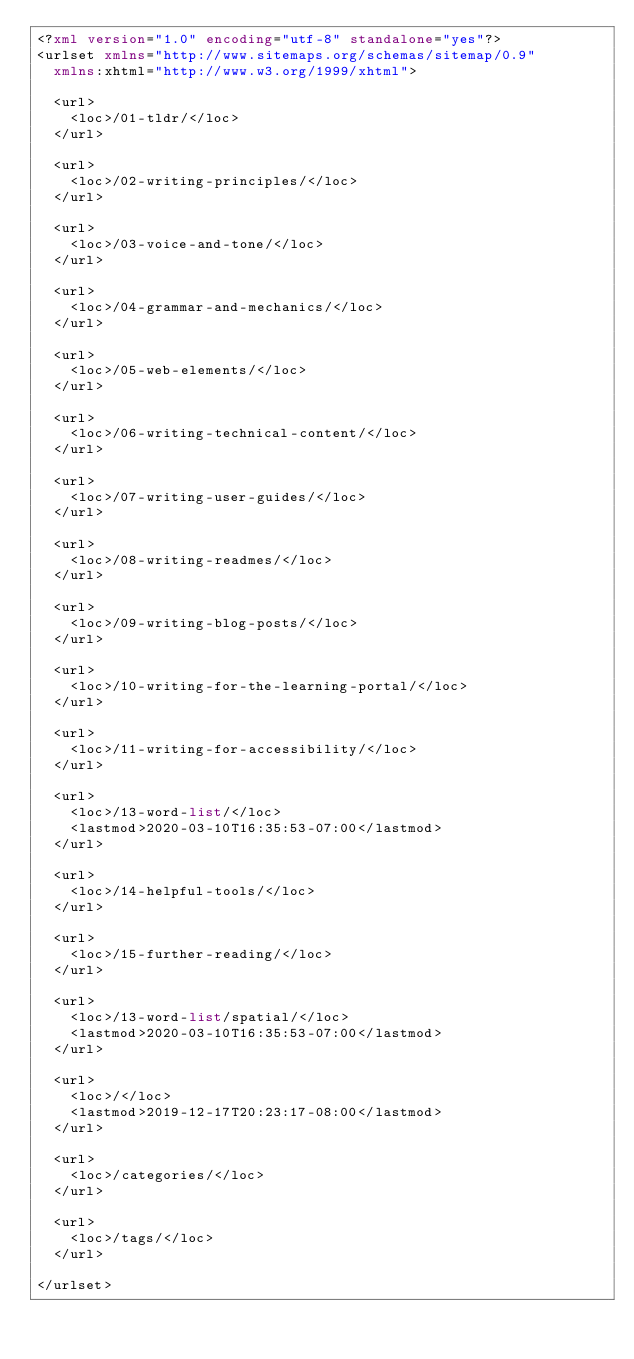Convert code to text. <code><loc_0><loc_0><loc_500><loc_500><_XML_><?xml version="1.0" encoding="utf-8" standalone="yes"?>
<urlset xmlns="http://www.sitemaps.org/schemas/sitemap/0.9"
  xmlns:xhtml="http://www.w3.org/1999/xhtml">
  
  <url>
    <loc>/01-tldr/</loc>
  </url>
  
  <url>
    <loc>/02-writing-principles/</loc>
  </url>
  
  <url>
    <loc>/03-voice-and-tone/</loc>
  </url>
  
  <url>
    <loc>/04-grammar-and-mechanics/</loc>
  </url>
  
  <url>
    <loc>/05-web-elements/</loc>
  </url>
  
  <url>
    <loc>/06-writing-technical-content/</loc>
  </url>
  
  <url>
    <loc>/07-writing-user-guides/</loc>
  </url>
  
  <url>
    <loc>/08-writing-readmes/</loc>
  </url>
  
  <url>
    <loc>/09-writing-blog-posts/</loc>
  </url>
  
  <url>
    <loc>/10-writing-for-the-learning-portal/</loc>
  </url>
  
  <url>
    <loc>/11-writing-for-accessibility/</loc>
  </url>
  
  <url>
    <loc>/13-word-list/</loc>
    <lastmod>2020-03-10T16:35:53-07:00</lastmod>
  </url>
  
  <url>
    <loc>/14-helpful-tools/</loc>
  </url>
  
  <url>
    <loc>/15-further-reading/</loc>
  </url>
  
  <url>
    <loc>/13-word-list/spatial/</loc>
    <lastmod>2020-03-10T16:35:53-07:00</lastmod>
  </url>
  
  <url>
    <loc>/</loc>
    <lastmod>2019-12-17T20:23:17-08:00</lastmod>
  </url>
  
  <url>
    <loc>/categories/</loc>
  </url>
  
  <url>
    <loc>/tags/</loc>
  </url>
  
</urlset>
</code> 